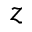<formula> <loc_0><loc_0><loc_500><loc_500>z</formula> 